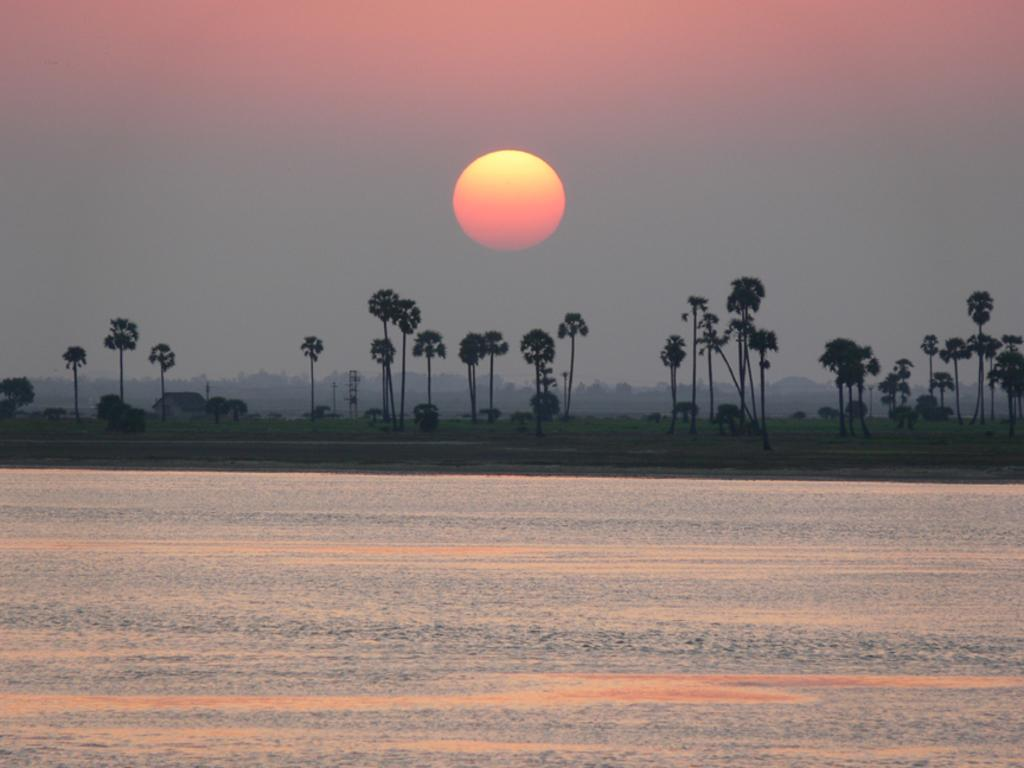What is visible at the bottom of the image? There is water visible at the bottom of the image. What can be seen in the background of the image? There are trees and grass in the background of the image. What is visible in the sky in the image? The sky is visible in the background of the image, and the sun is observable in the sky. How many mice are hiding in the bedroom in the image? There is no bedroom or mice present in the image. What type of crow can be seen interacting with the trees in the image? There are no crows present in the image; only trees and grass are visible in the background. 